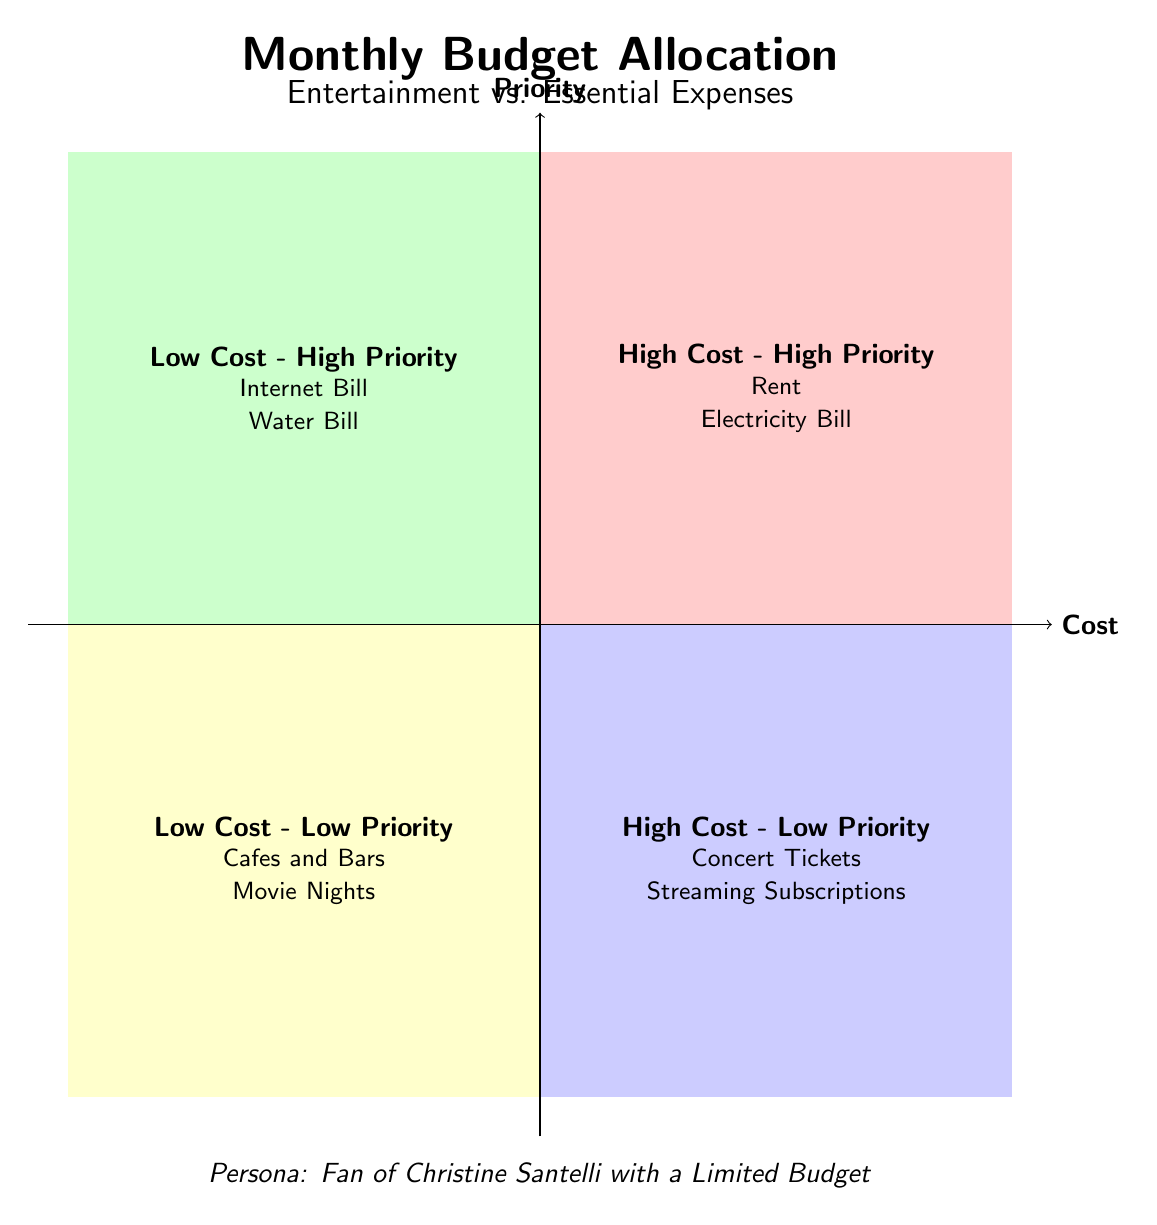What elements are categorized as High Cost - High Priority? According to the quadrants defined in the diagram, the High Cost - High Priority quadrant contains elements categorized as Rent and Electricity Bill.
Answer: Rent, Electricity Bill How many elements are listed in the Low Cost - Low Priority quadrant? The Low Cost - Low Priority quadrant includes two elements: Cafes and Bars, and Movie Nights, making a total of two elements in this quadrant.
Answer: 2 Which element represents entertainment in the High Cost - Low Priority quadrant? The diagram indicates that the element representing entertainment in the High Cost - Low Priority quadrant is Concert Tickets.
Answer: Concert Tickets What is the description of the element in the Low Cost - High Priority quadrant related to internet services? The description for the element in the Low Cost - High Priority quadrant related to internet services is "Monthly cost of internet services."
Answer: Monthly cost of internet services Which quadrant contains both essential and entertainment expenses? The diagram shows that the High Cost - High Priority quadrant contains essential expenses while the High Cost - Low Priority quadrant contains entertainment expenses, but there is no quadrant that contains both types together.
Answer: None What is the primary characteristic of elements in the High Cost - Low Priority quadrant? The primary characteristic of elements in the High Cost - Low Priority quadrant is that they are expensive but not considered essential, as they include Concert Tickets and Streaming Subscriptions.
Answer: Expensive but not essential Which quadrant has the lowest priorities in terms of cost and importance? The quadrant with the lowest priorities in terms of cost and importance is the Low Cost - Low Priority quadrant.
Answer: Low Cost - Low Priority How many quadrants are filled with elements in the diagram? The diagram features all four quadrants filled with elements, each representing different priorities and costs.
Answer: 4 What type of expenses are categorized in the Q1 quadrant? The Q1 quadrant categorizes essential expenses, specifically those that are high cost and high priority.
Answer: Essential Expenses 